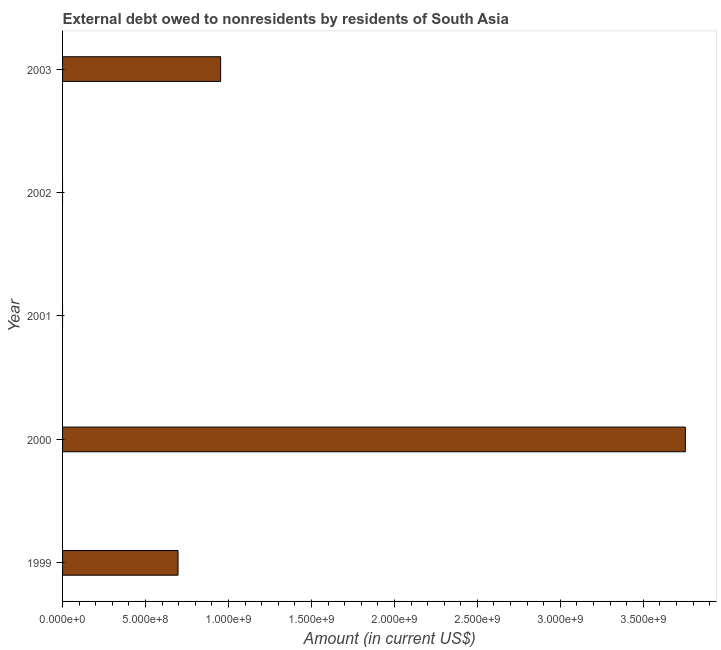Does the graph contain grids?
Your answer should be compact. No. What is the title of the graph?
Offer a very short reply. External debt owed to nonresidents by residents of South Asia. What is the debt in 2003?
Ensure brevity in your answer.  9.53e+08. Across all years, what is the maximum debt?
Keep it short and to the point. 3.75e+09. In which year was the debt maximum?
Your response must be concise. 2000. What is the sum of the debt?
Provide a succinct answer. 5.40e+09. What is the difference between the debt in 1999 and 2000?
Your answer should be very brief. -3.06e+09. What is the average debt per year?
Your answer should be compact. 1.08e+09. What is the median debt?
Ensure brevity in your answer.  6.96e+08. What is the difference between the highest and the second highest debt?
Give a very brief answer. 2.80e+09. What is the difference between the highest and the lowest debt?
Ensure brevity in your answer.  3.75e+09. How many bars are there?
Your answer should be compact. 3. Are the values on the major ticks of X-axis written in scientific E-notation?
Offer a terse response. Yes. What is the Amount (in current US$) in 1999?
Keep it short and to the point. 6.96e+08. What is the Amount (in current US$) of 2000?
Provide a succinct answer. 3.75e+09. What is the Amount (in current US$) of 2003?
Keep it short and to the point. 9.53e+08. What is the difference between the Amount (in current US$) in 1999 and 2000?
Make the answer very short. -3.06e+09. What is the difference between the Amount (in current US$) in 1999 and 2003?
Your response must be concise. -2.57e+08. What is the difference between the Amount (in current US$) in 2000 and 2003?
Keep it short and to the point. 2.80e+09. What is the ratio of the Amount (in current US$) in 1999 to that in 2000?
Offer a very short reply. 0.18. What is the ratio of the Amount (in current US$) in 1999 to that in 2003?
Give a very brief answer. 0.73. What is the ratio of the Amount (in current US$) in 2000 to that in 2003?
Your answer should be compact. 3.94. 